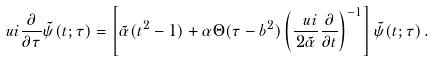Convert formula to latex. <formula><loc_0><loc_0><loc_500><loc_500>\ u i \frac { \partial } { \partial \tau } \tilde { \psi } ( t ; \tau ) = \left [ \tilde { \alpha } ( t ^ { 2 } - 1 ) + \alpha \Theta ( \tau - b ^ { 2 } ) \left ( \frac { \ u i } { 2 \tilde { \alpha } } \frac { \partial } { \partial t } \right ) ^ { - 1 } \right ] \tilde { \psi } ( t ; \tau ) \, .</formula> 